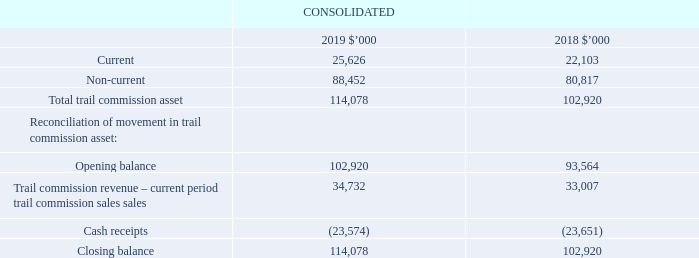3.4 Trail commission asset
Recognition, measurement and classification
The Group has elected to account for trail commission revenue at the time of selling a product to which trail commission attaches, rather than on the basis of actual payments received from the relevant fund or providers involved. On initial recognition, trail commission revenue and assets are recognised at expected value. Subsequent to initial recognition and measurement, the carrying amount of the trail commission asset is adjusted to reflect actual and revised estimated cash flows. The resulting adjustment is recognised as revenue or against revenue in profit or loss.
Cash receipts that are expected to be received within 12 months of the reporting date are classified as current. All other expected cash receipts are classified as non-current.
Key estimates – trail commission revenue and asset
This method of revenue recognition and valuation of trail commission asset requires the Directors and management to make certain estimates and assumptions based on industry data and the historical experience of the Group.
Attrition rates in Health are particularly relevant to the overall trail commission asset considering the relative size of the Health trail commission asset. Attrition rates vary substantially by provider and also by the duration of time the policy has been in force, with rates generally higher in policies under two years old. The attrition rates used in the valuation of the Health portfolio at 30 June 2019 ranged from 7.5% and 26.5% (2018: 7.5% and 26.5%). The simple average duration band attrition increase was up to 0.2% during the period, with higher increases experienced for policies that have been in force for shorter periods of time.
In undertaking this responsibility, the Group engages Deloitte Actuaries and Consultants Limited, a firm of consulting actuaries, to assist in reviewing the accuracy of assumptions for health, mortgages and life trail revenue. These estimates and assumptions include, but are not limited to: termination or lapse rates, mortality rates, inflation, forecast fund premium increases and the estimated impact of known Australian Federal and State Government policies.
These variable considerations are constrained to the extent that it is highly probable that a significant reversal in the amount of cumulative revenue recognised will not occur when the uncertainty associated with the variable consideration is subsequently resolved. In determining the extent of constraint necessary to ensure to a high probability that a significant reversal of revenue will not occur, the Group performs a detailed assessment of the accuracy of previously forecast assumptions against historical results.
Which cash receipts are classified as current? Cash receipts that are expected to be received within 12 months of the reporting date. What is the range of the attrition rates used in the valuation of the Health portfolio at 30 June 2019? 7.5% and 26.5%. What was the increase in the average duration band attrition in 2019? Up to 0.2%. What is the percentage change in the current trail commission asset from 2018 to 2019?
Answer scale should be: percent. (25,626-22,103)/22,103
Answer: 15.94. What is the percentage change in the total trail commission asset from 2018 to 2019?
Answer scale should be: percent. (114,078-102,920)/102,920
Answer: 10.84. What is the percentage change in the cash receipts from 2018 to 2019?
Answer scale should be: percent. (23,574-23,651)/23,651
Answer: -0.33. 